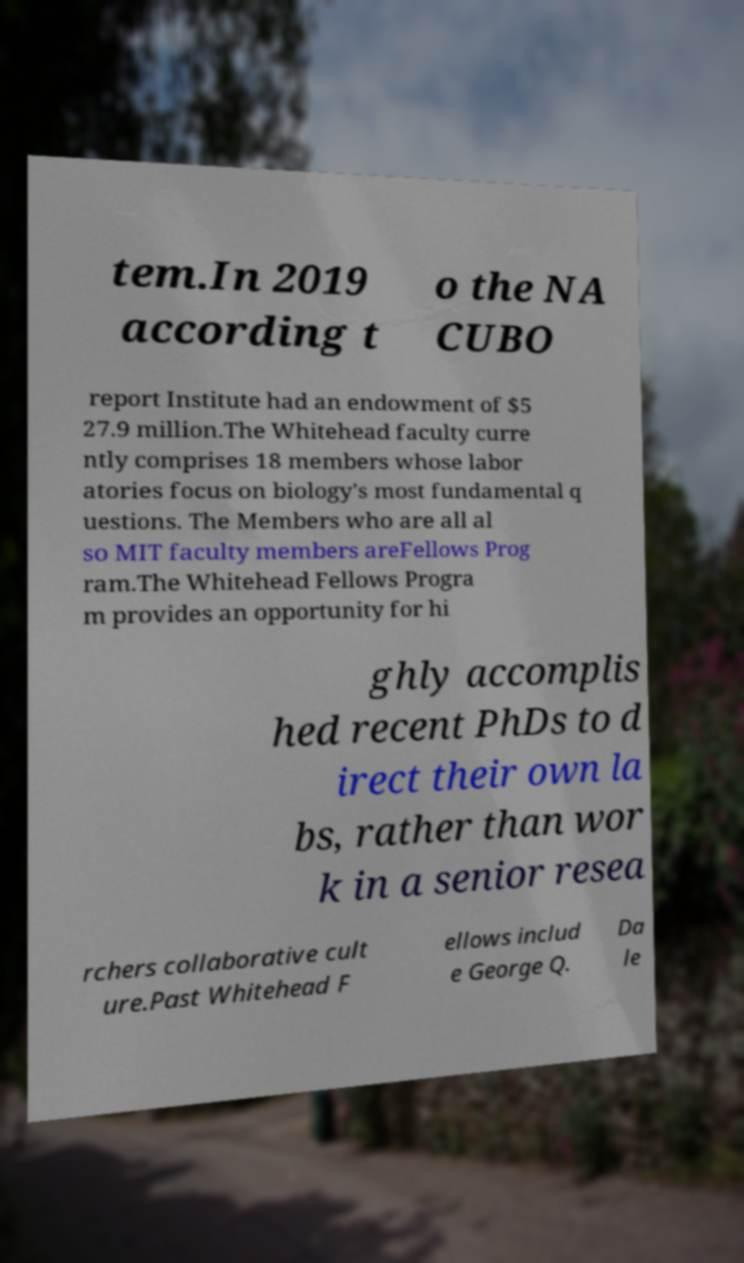There's text embedded in this image that I need extracted. Can you transcribe it verbatim? tem.In 2019 according t o the NA CUBO report Institute had an endowment of $5 27.9 million.The Whitehead faculty curre ntly comprises 18 members whose labor atories focus on biology's most fundamental q uestions. The Members who are all al so MIT faculty members areFellows Prog ram.The Whitehead Fellows Progra m provides an opportunity for hi ghly accomplis hed recent PhDs to d irect their own la bs, rather than wor k in a senior resea rchers collaborative cult ure.Past Whitehead F ellows includ e George Q. Da le 